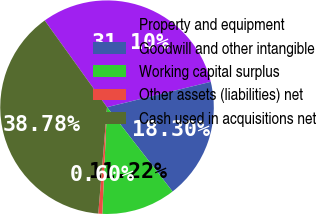Convert chart. <chart><loc_0><loc_0><loc_500><loc_500><pie_chart><fcel>Property and equipment<fcel>Goodwill and other intangible<fcel>Working capital surplus<fcel>Other assets (liabilities) net<fcel>Cash used in acquisitions net<nl><fcel>31.1%<fcel>18.3%<fcel>11.22%<fcel>0.6%<fcel>38.78%<nl></chart> 